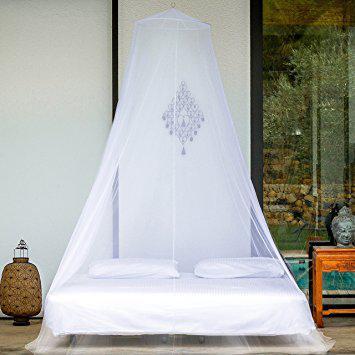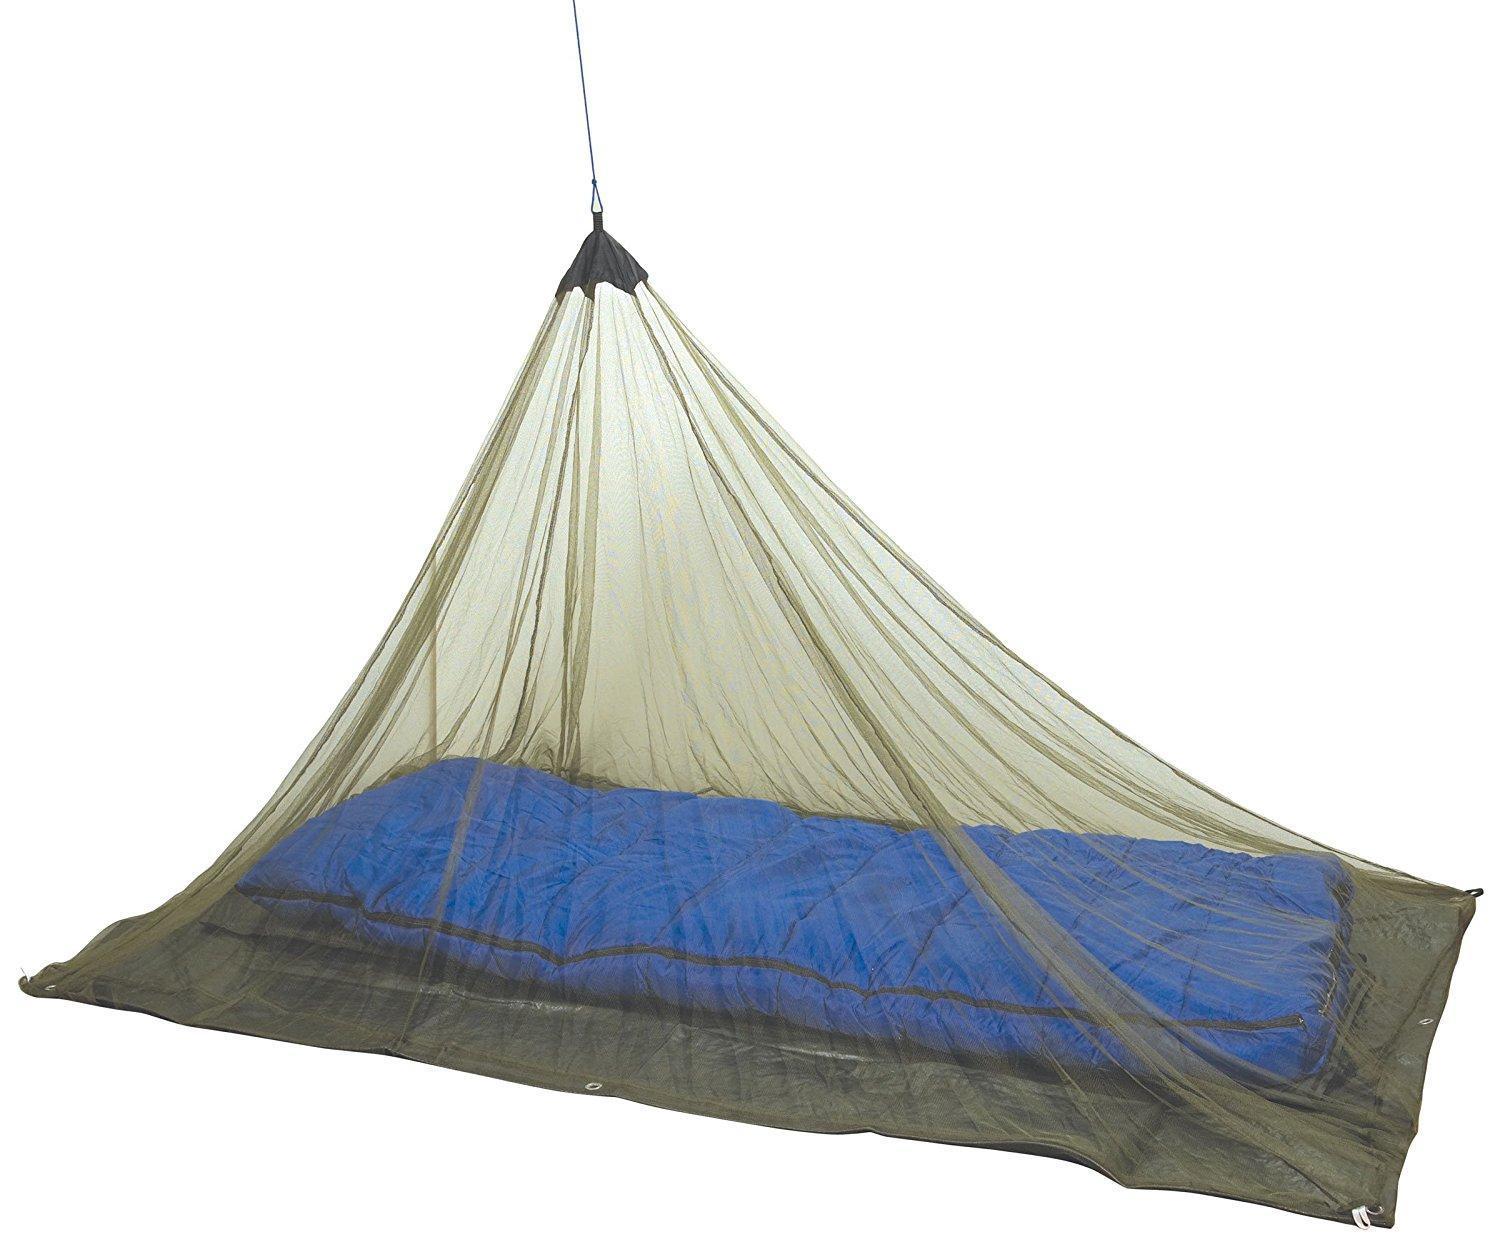The first image is the image on the left, the second image is the image on the right. Assess this claim about the two images: "One image on a white background shows a simple protective bed net that gathers to a point.". Correct or not? Answer yes or no. Yes. The first image is the image on the left, the second image is the image on the right. Assess this claim about the two images: "Two mattresses are completely covered by draped mosquito netting.". Correct or not? Answer yes or no. Yes. 